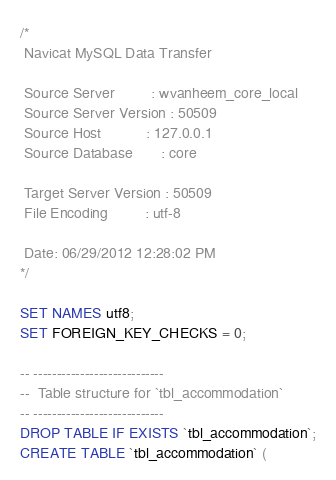<code> <loc_0><loc_0><loc_500><loc_500><_SQL_>/*
 Navicat MySQL Data Transfer

 Source Server         : wvanheem_core_local
 Source Server Version : 50509
 Source Host           : 127.0.0.1
 Source Database       : core

 Target Server Version : 50509
 File Encoding         : utf-8

 Date: 06/29/2012 12:28:02 PM
*/

SET NAMES utf8;
SET FOREIGN_KEY_CHECKS = 0;

-- ----------------------------
--  Table structure for `tbl_accommodation`
-- ----------------------------
DROP TABLE IF EXISTS `tbl_accommodation`;
CREATE TABLE `tbl_accommodation` (</code> 